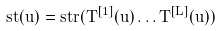<formula> <loc_0><loc_0><loc_500><loc_500>s t ( u ) = s t r ( T ^ { [ 1 ] } ( u ) \dots T ^ { [ L ] } ( u ) )</formula> 